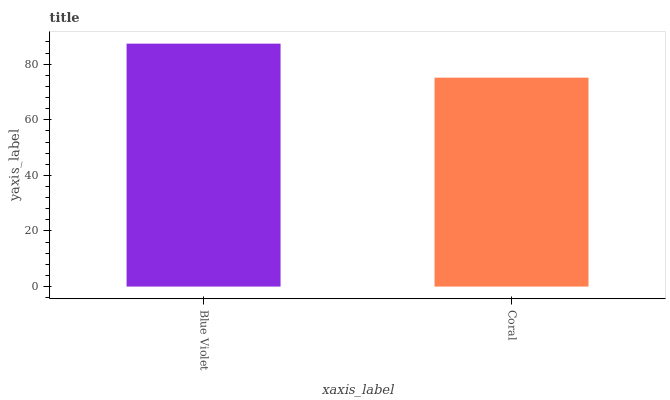Is Coral the minimum?
Answer yes or no. Yes. Is Blue Violet the maximum?
Answer yes or no. Yes. Is Coral the maximum?
Answer yes or no. No. Is Blue Violet greater than Coral?
Answer yes or no. Yes. Is Coral less than Blue Violet?
Answer yes or no. Yes. Is Coral greater than Blue Violet?
Answer yes or no. No. Is Blue Violet less than Coral?
Answer yes or no. No. Is Blue Violet the high median?
Answer yes or no. Yes. Is Coral the low median?
Answer yes or no. Yes. Is Coral the high median?
Answer yes or no. No. Is Blue Violet the low median?
Answer yes or no. No. 